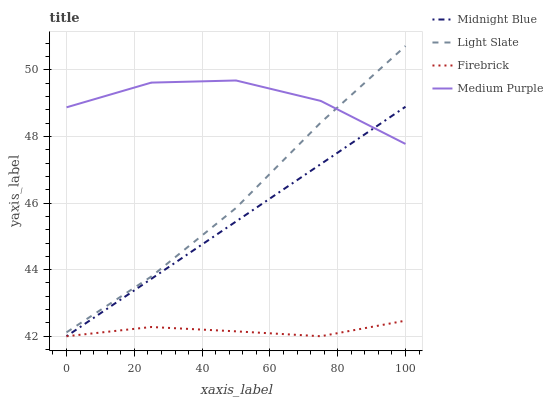Does Firebrick have the minimum area under the curve?
Answer yes or no. Yes. Does Medium Purple have the maximum area under the curve?
Answer yes or no. Yes. Does Medium Purple have the minimum area under the curve?
Answer yes or no. No. Does Firebrick have the maximum area under the curve?
Answer yes or no. No. Is Midnight Blue the smoothest?
Answer yes or no. Yes. Is Medium Purple the roughest?
Answer yes or no. Yes. Is Firebrick the smoothest?
Answer yes or no. No. Is Firebrick the roughest?
Answer yes or no. No. Does Medium Purple have the lowest value?
Answer yes or no. No. Does Medium Purple have the highest value?
Answer yes or no. No. Is Firebrick less than Light Slate?
Answer yes or no. Yes. Is Medium Purple greater than Firebrick?
Answer yes or no. Yes. Does Firebrick intersect Light Slate?
Answer yes or no. No. 